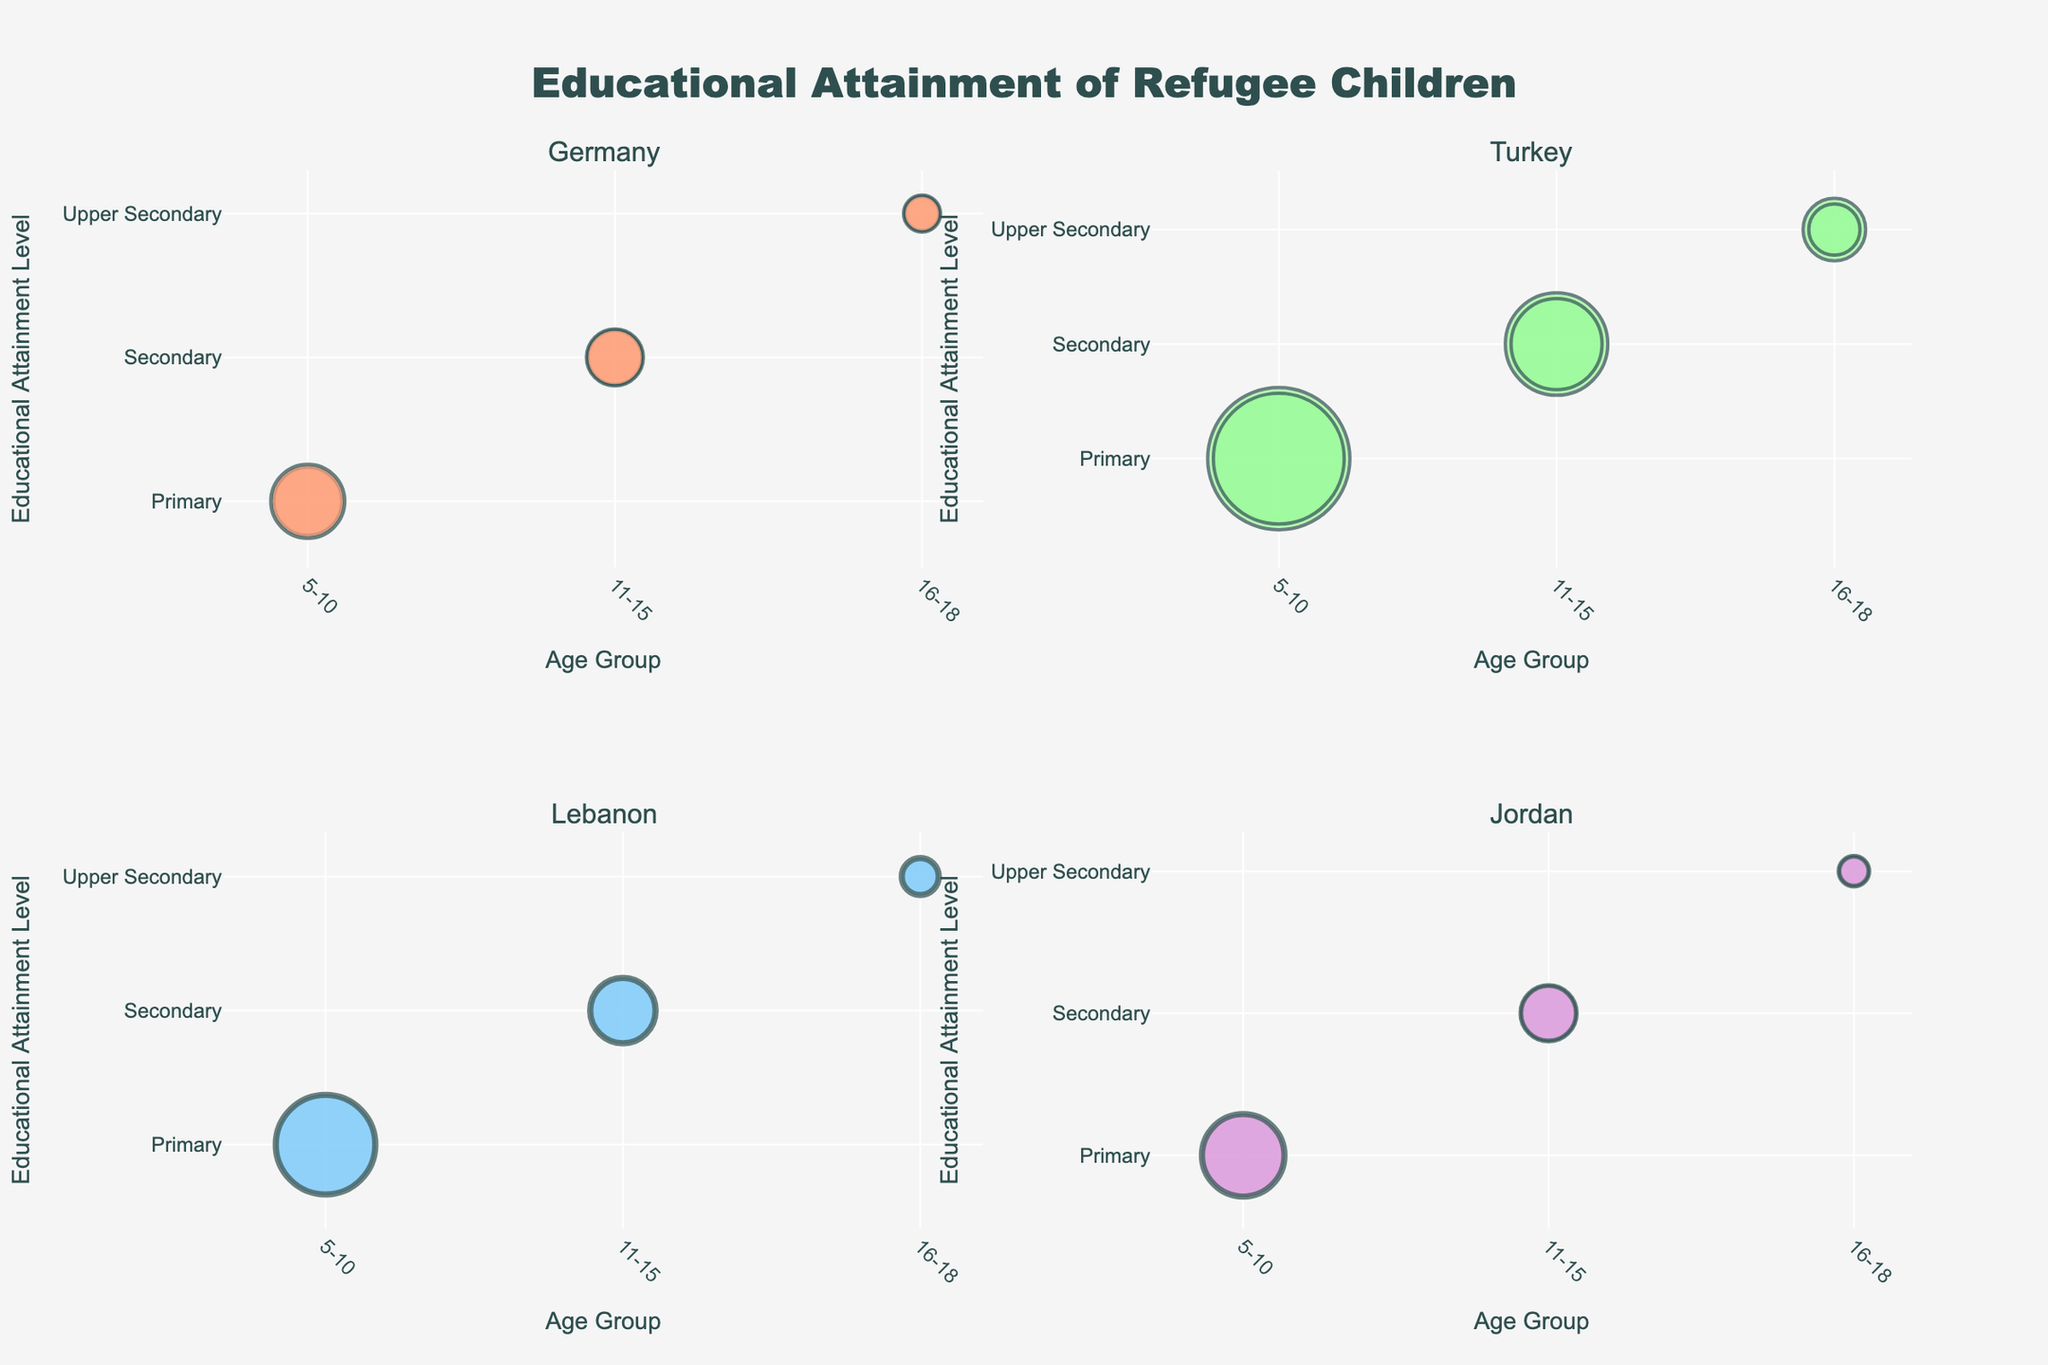What is the title of the figure? The title of the figure is usually at the top center in large font. Here, you can read the title "Educational Attainment of Refugee Children" from the figure.
Answer: Educational Attainment of Refugee Children How many host countries are shown in the figure? Each subplot represents a different host country. There are four subplots, so there are four host countries shown.
Answer: Four Which host country has the highest number of primary-level refugee children in the 5-10 age group? Examine the size of the bubbles in the subplots for the 5-10 age group. Turkey has the largest bubbles for the primary level, indicating the highest number.
Answer: Turkey What is the combined number of female refugee children in the secondary level (age group 11-15) across all host countries? Look at the bubbles representing secondary education for females aged 11-15 in each subplot and sum up the numbers (1000 in Germany, 1600 in Turkey, 1100 in Lebanon, 950 in Jordan). 1000 + 1600 + 1100 + 950 = 4650.
Answer: 4650 What color represents the data for Germany? Each subplot is colored differently. Germany’s data uses a distinct color. By examining Germany's subplot, we see that it is represented by one of the predefined colors, likely '#FFA07A' or a similar color.
Answer: Light Salmon (or similar to #FFA07A) Which gender has more children in the upper secondary education in Lebanon? Compare the bubble sizes for males and females in upper secondary education within the Lebanon subplot. The bubbles show more children for males (700) than females (600).
Answer: Male What is the difference in the number of secondary-level refugee children (age group 11-15) between Turkey and Germany? Identify the number for secondary-level children in both countries, then subtract Germany's count (950+1000) from Turkey's count (1800+1600). 3400 (Turkey) - 1950 (Germany) = 1450.
Answer: 1450 Which age group has the smallest bubble across all subplots for the host country of Jordan? Examine all bubbles in Jordan’s subplot. The smallest bubble is in the upper secondary age group, indicating the smallest number of children.
Answer: Upper Secondary How does the number of primary-level refugee children in Germany compare to that in Jordan for the 5-10 age group? By comparing bubble sizes in the Primary section of Germany and Jordan’s subplot for the 5-10 age group, Germany has 2500 + 2300 while Jordan has 1500 + 1400. Germany has larger numbers.
Answer: Germany has more 